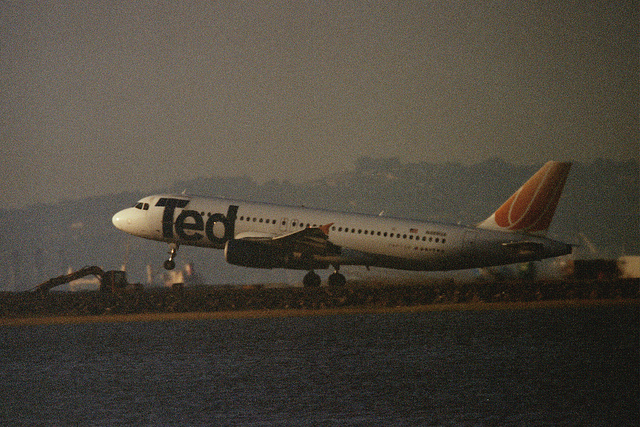Please identify all text content in this image. Ted 